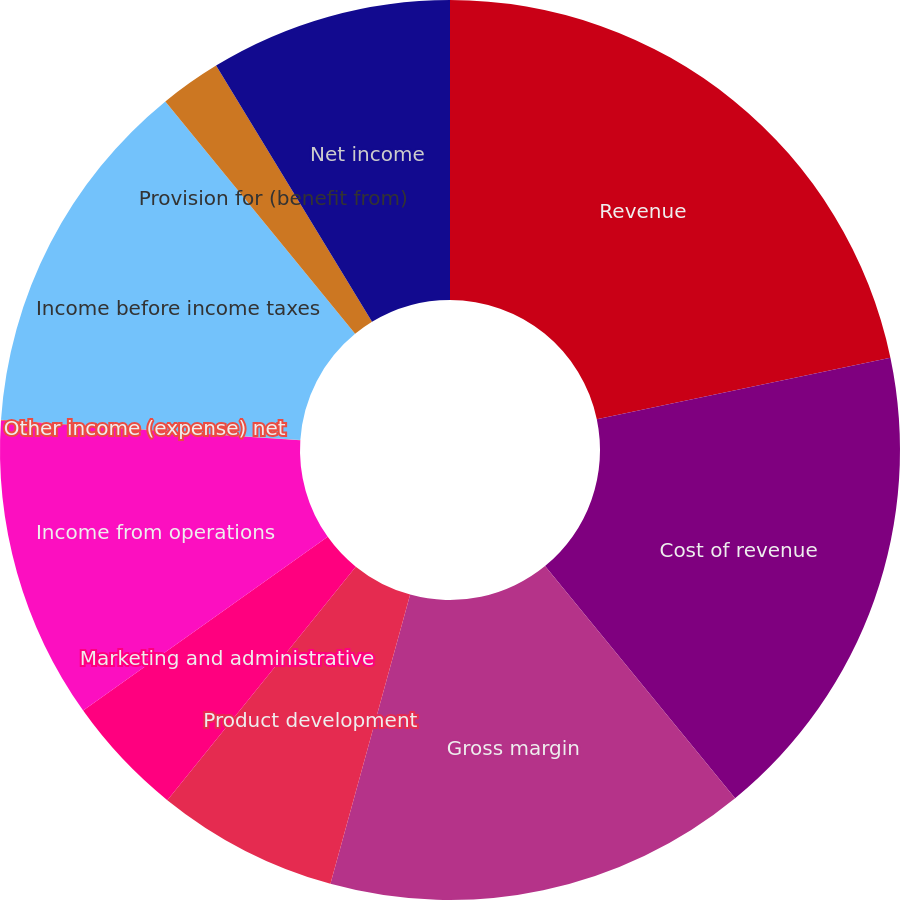<chart> <loc_0><loc_0><loc_500><loc_500><pie_chart><fcel>Revenue<fcel>Cost of revenue<fcel>Gross margin<fcel>Product development<fcel>Marketing and administrative<fcel>Income from operations<fcel>Other income (expense) net<fcel>Income before income taxes<fcel>Provision for (benefit from)<fcel>Net income<nl><fcel>21.71%<fcel>17.37%<fcel>15.2%<fcel>6.53%<fcel>4.36%<fcel>10.87%<fcel>0.03%<fcel>13.03%<fcel>2.2%<fcel>8.7%<nl></chart> 